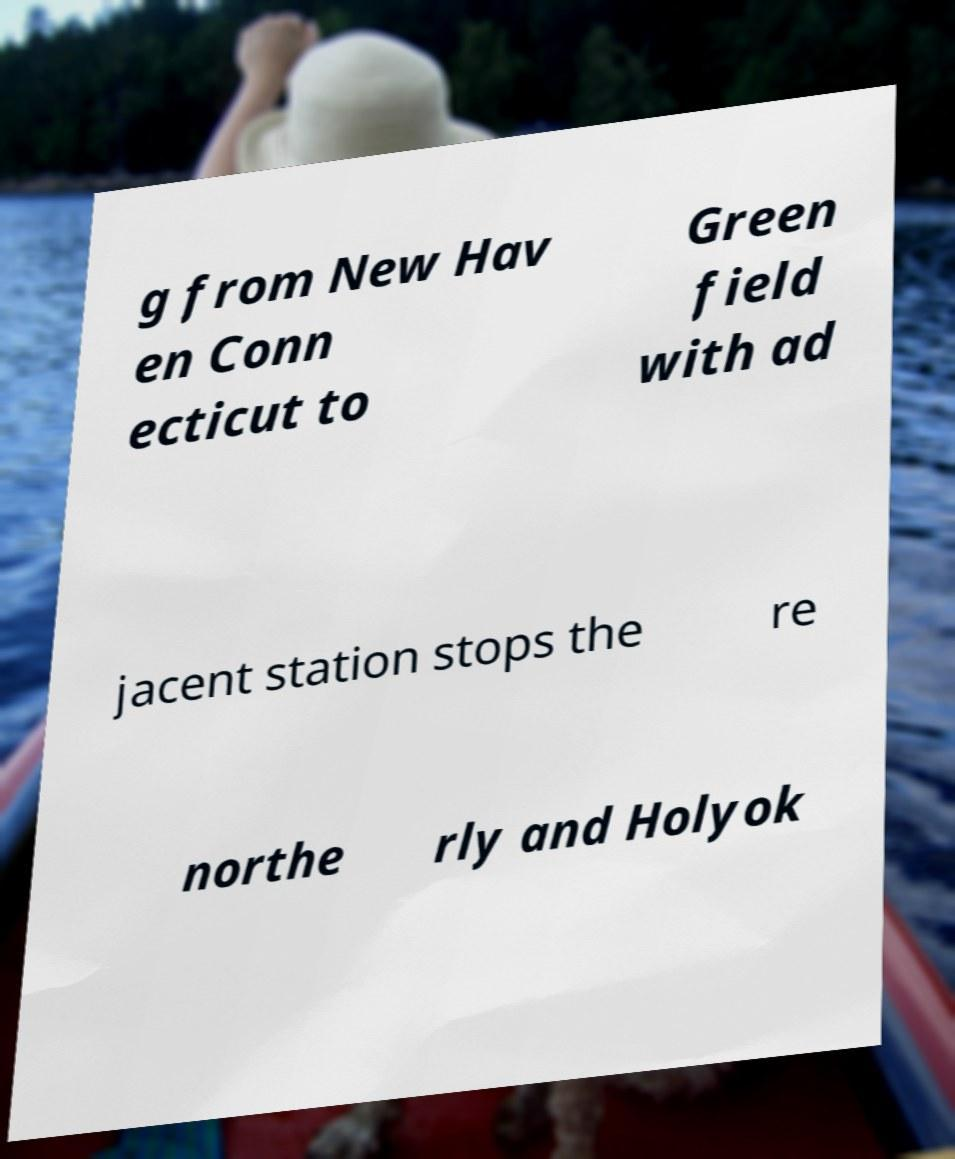I need the written content from this picture converted into text. Can you do that? g from New Hav en Conn ecticut to Green field with ad jacent station stops the re northe rly and Holyok 